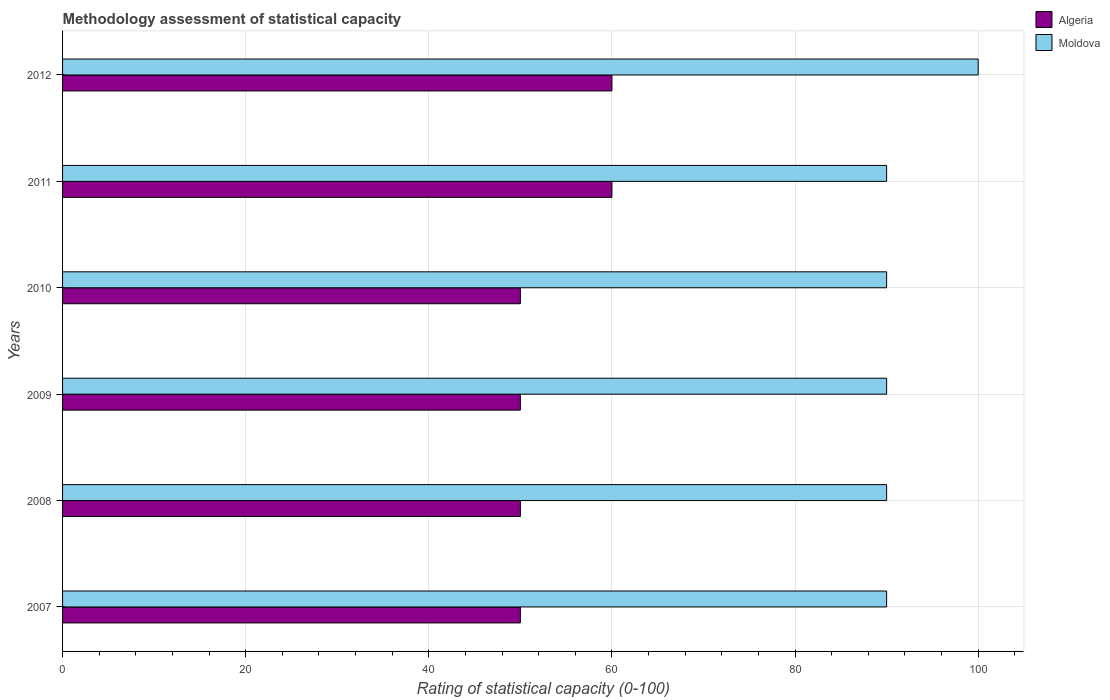How many different coloured bars are there?
Offer a very short reply. 2. How many bars are there on the 5th tick from the bottom?
Make the answer very short. 2. What is the rating of statistical capacity in Moldova in 2010?
Provide a short and direct response. 90. Across all years, what is the maximum rating of statistical capacity in Moldova?
Your response must be concise. 100. Across all years, what is the minimum rating of statistical capacity in Moldova?
Offer a terse response. 90. What is the total rating of statistical capacity in Algeria in the graph?
Offer a very short reply. 320. What is the difference between the rating of statistical capacity in Algeria in 2009 and that in 2012?
Your answer should be very brief. -10. What is the difference between the rating of statistical capacity in Moldova in 2010 and the rating of statistical capacity in Algeria in 2012?
Your answer should be very brief. 30. What is the average rating of statistical capacity in Moldova per year?
Provide a short and direct response. 91.67. In the year 2012, what is the difference between the rating of statistical capacity in Moldova and rating of statistical capacity in Algeria?
Provide a succinct answer. 40. In how many years, is the rating of statistical capacity in Moldova greater than 4 ?
Give a very brief answer. 6. What is the ratio of the rating of statistical capacity in Algeria in 2009 to that in 2012?
Ensure brevity in your answer.  0.83. Is the difference between the rating of statistical capacity in Moldova in 2007 and 2008 greater than the difference between the rating of statistical capacity in Algeria in 2007 and 2008?
Ensure brevity in your answer.  No. What is the difference between the highest and the second highest rating of statistical capacity in Algeria?
Give a very brief answer. 0. What is the difference between the highest and the lowest rating of statistical capacity in Algeria?
Your answer should be very brief. 10. What does the 2nd bar from the top in 2009 represents?
Provide a short and direct response. Algeria. What does the 1st bar from the bottom in 2011 represents?
Offer a very short reply. Algeria. Are all the bars in the graph horizontal?
Provide a succinct answer. Yes. Are the values on the major ticks of X-axis written in scientific E-notation?
Your response must be concise. No. Does the graph contain any zero values?
Your response must be concise. No. How are the legend labels stacked?
Your answer should be very brief. Vertical. What is the title of the graph?
Your answer should be very brief. Methodology assessment of statistical capacity. Does "Israel" appear as one of the legend labels in the graph?
Offer a terse response. No. What is the label or title of the X-axis?
Your answer should be compact. Rating of statistical capacity (0-100). What is the label or title of the Y-axis?
Offer a terse response. Years. What is the Rating of statistical capacity (0-100) in Algeria in 2007?
Provide a short and direct response. 50. What is the Rating of statistical capacity (0-100) in Moldova in 2007?
Your answer should be compact. 90. What is the Rating of statistical capacity (0-100) of Algeria in 2010?
Keep it short and to the point. 50. What is the Rating of statistical capacity (0-100) of Moldova in 2010?
Your answer should be very brief. 90. What is the Rating of statistical capacity (0-100) of Algeria in 2012?
Your answer should be very brief. 60. Across all years, what is the maximum Rating of statistical capacity (0-100) in Algeria?
Keep it short and to the point. 60. Across all years, what is the maximum Rating of statistical capacity (0-100) in Moldova?
Your answer should be compact. 100. Across all years, what is the minimum Rating of statistical capacity (0-100) in Algeria?
Ensure brevity in your answer.  50. Across all years, what is the minimum Rating of statistical capacity (0-100) of Moldova?
Give a very brief answer. 90. What is the total Rating of statistical capacity (0-100) in Algeria in the graph?
Make the answer very short. 320. What is the total Rating of statistical capacity (0-100) in Moldova in the graph?
Make the answer very short. 550. What is the difference between the Rating of statistical capacity (0-100) in Algeria in 2007 and that in 2011?
Your response must be concise. -10. What is the difference between the Rating of statistical capacity (0-100) of Moldova in 2007 and that in 2012?
Offer a very short reply. -10. What is the difference between the Rating of statistical capacity (0-100) of Algeria in 2008 and that in 2010?
Keep it short and to the point. 0. What is the difference between the Rating of statistical capacity (0-100) in Moldova in 2008 and that in 2010?
Provide a succinct answer. 0. What is the difference between the Rating of statistical capacity (0-100) of Algeria in 2008 and that in 2011?
Give a very brief answer. -10. What is the difference between the Rating of statistical capacity (0-100) in Algeria in 2008 and that in 2012?
Offer a very short reply. -10. What is the difference between the Rating of statistical capacity (0-100) of Moldova in 2008 and that in 2012?
Your answer should be very brief. -10. What is the difference between the Rating of statistical capacity (0-100) of Algeria in 2009 and that in 2010?
Keep it short and to the point. 0. What is the difference between the Rating of statistical capacity (0-100) in Moldova in 2009 and that in 2011?
Your response must be concise. 0. What is the difference between the Rating of statistical capacity (0-100) in Moldova in 2009 and that in 2012?
Make the answer very short. -10. What is the difference between the Rating of statistical capacity (0-100) of Moldova in 2010 and that in 2011?
Your answer should be compact. 0. What is the difference between the Rating of statistical capacity (0-100) of Moldova in 2010 and that in 2012?
Your response must be concise. -10. What is the difference between the Rating of statistical capacity (0-100) in Algeria in 2011 and that in 2012?
Make the answer very short. 0. What is the difference between the Rating of statistical capacity (0-100) of Algeria in 2008 and the Rating of statistical capacity (0-100) of Moldova in 2011?
Keep it short and to the point. -40. What is the difference between the Rating of statistical capacity (0-100) of Algeria in 2008 and the Rating of statistical capacity (0-100) of Moldova in 2012?
Provide a short and direct response. -50. What is the difference between the Rating of statistical capacity (0-100) in Algeria in 2009 and the Rating of statistical capacity (0-100) in Moldova in 2010?
Provide a succinct answer. -40. What is the difference between the Rating of statistical capacity (0-100) of Algeria in 2009 and the Rating of statistical capacity (0-100) of Moldova in 2011?
Ensure brevity in your answer.  -40. What is the difference between the Rating of statistical capacity (0-100) of Algeria in 2009 and the Rating of statistical capacity (0-100) of Moldova in 2012?
Keep it short and to the point. -50. What is the difference between the Rating of statistical capacity (0-100) in Algeria in 2010 and the Rating of statistical capacity (0-100) in Moldova in 2011?
Offer a very short reply. -40. What is the difference between the Rating of statistical capacity (0-100) of Algeria in 2010 and the Rating of statistical capacity (0-100) of Moldova in 2012?
Offer a very short reply. -50. What is the average Rating of statistical capacity (0-100) in Algeria per year?
Provide a succinct answer. 53.33. What is the average Rating of statistical capacity (0-100) in Moldova per year?
Your answer should be compact. 91.67. In the year 2009, what is the difference between the Rating of statistical capacity (0-100) of Algeria and Rating of statistical capacity (0-100) of Moldova?
Make the answer very short. -40. In the year 2010, what is the difference between the Rating of statistical capacity (0-100) in Algeria and Rating of statistical capacity (0-100) in Moldova?
Give a very brief answer. -40. In the year 2011, what is the difference between the Rating of statistical capacity (0-100) in Algeria and Rating of statistical capacity (0-100) in Moldova?
Provide a succinct answer. -30. What is the ratio of the Rating of statistical capacity (0-100) in Algeria in 2007 to that in 2009?
Your answer should be compact. 1. What is the ratio of the Rating of statistical capacity (0-100) in Moldova in 2007 to that in 2009?
Your answer should be compact. 1. What is the ratio of the Rating of statistical capacity (0-100) of Moldova in 2007 to that in 2010?
Provide a short and direct response. 1. What is the ratio of the Rating of statistical capacity (0-100) in Algeria in 2007 to that in 2012?
Offer a terse response. 0.83. What is the ratio of the Rating of statistical capacity (0-100) in Moldova in 2007 to that in 2012?
Make the answer very short. 0.9. What is the ratio of the Rating of statistical capacity (0-100) of Moldova in 2008 to that in 2009?
Make the answer very short. 1. What is the ratio of the Rating of statistical capacity (0-100) in Algeria in 2008 to that in 2011?
Your answer should be very brief. 0.83. What is the ratio of the Rating of statistical capacity (0-100) of Moldova in 2008 to that in 2012?
Give a very brief answer. 0.9. What is the ratio of the Rating of statistical capacity (0-100) in Moldova in 2009 to that in 2010?
Ensure brevity in your answer.  1. What is the ratio of the Rating of statistical capacity (0-100) of Algeria in 2009 to that in 2011?
Keep it short and to the point. 0.83. What is the ratio of the Rating of statistical capacity (0-100) of Moldova in 2010 to that in 2011?
Give a very brief answer. 1. What is the difference between the highest and the second highest Rating of statistical capacity (0-100) in Algeria?
Your answer should be very brief. 0. What is the difference between the highest and the second highest Rating of statistical capacity (0-100) in Moldova?
Provide a short and direct response. 10. What is the difference between the highest and the lowest Rating of statistical capacity (0-100) in Algeria?
Keep it short and to the point. 10. 